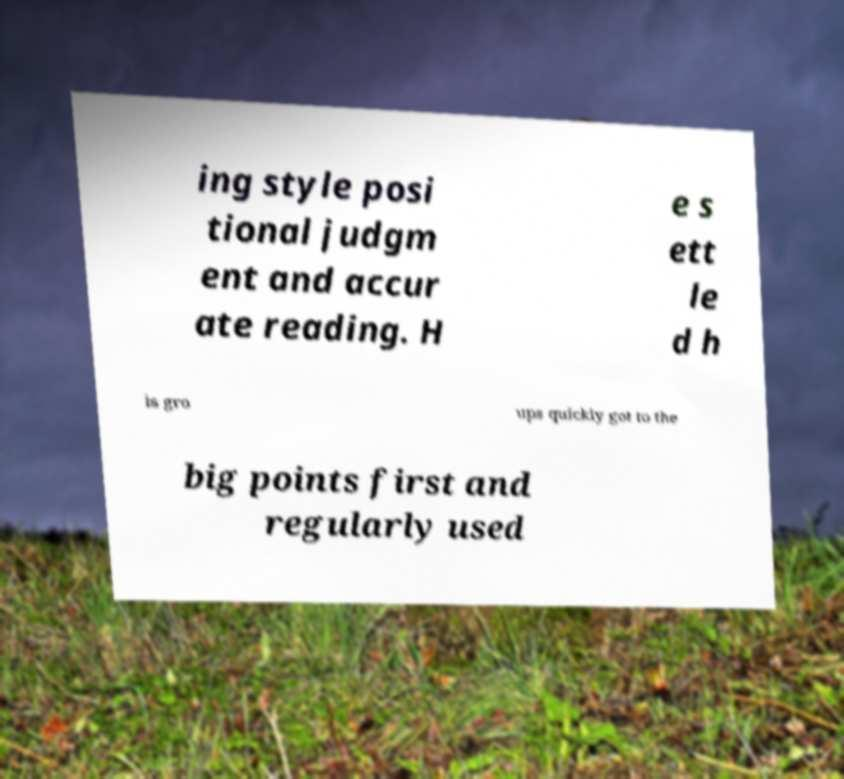Can you read and provide the text displayed in the image?This photo seems to have some interesting text. Can you extract and type it out for me? ing style posi tional judgm ent and accur ate reading. H e s ett le d h is gro ups quickly got to the big points first and regularly used 